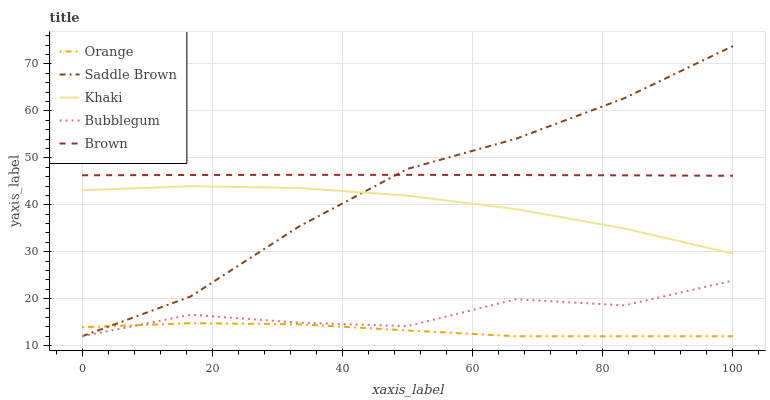Does Orange have the minimum area under the curve?
Answer yes or no. Yes. Does Brown have the maximum area under the curve?
Answer yes or no. Yes. Does Khaki have the minimum area under the curve?
Answer yes or no. No. Does Khaki have the maximum area under the curve?
Answer yes or no. No. Is Brown the smoothest?
Answer yes or no. Yes. Is Bubblegum the roughest?
Answer yes or no. Yes. Is Khaki the smoothest?
Answer yes or no. No. Is Khaki the roughest?
Answer yes or no. No. Does Orange have the lowest value?
Answer yes or no. Yes. Does Khaki have the lowest value?
Answer yes or no. No. Does Saddle Brown have the highest value?
Answer yes or no. Yes. Does Brown have the highest value?
Answer yes or no. No. Is Bubblegum less than Brown?
Answer yes or no. Yes. Is Khaki greater than Orange?
Answer yes or no. Yes. Does Saddle Brown intersect Khaki?
Answer yes or no. Yes. Is Saddle Brown less than Khaki?
Answer yes or no. No. Is Saddle Brown greater than Khaki?
Answer yes or no. No. Does Bubblegum intersect Brown?
Answer yes or no. No. 